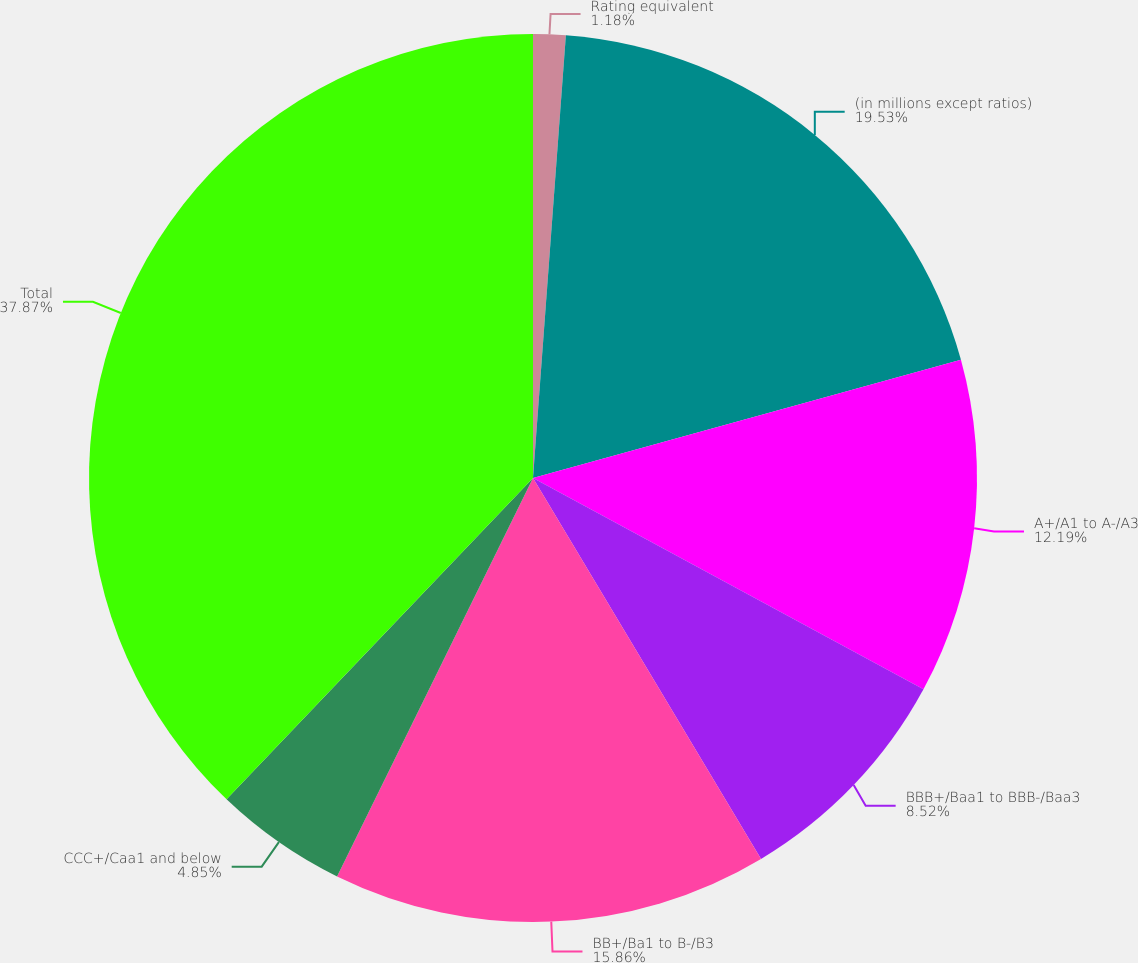Convert chart to OTSL. <chart><loc_0><loc_0><loc_500><loc_500><pie_chart><fcel>Rating equivalent<fcel>(in millions except ratios)<fcel>A+/A1 to A-/A3<fcel>BBB+/Baa1 to BBB-/Baa3<fcel>BB+/Ba1 to B-/B3<fcel>CCC+/Caa1 and below<fcel>Total<nl><fcel>1.18%<fcel>19.53%<fcel>12.19%<fcel>8.52%<fcel>15.86%<fcel>4.85%<fcel>37.88%<nl></chart> 